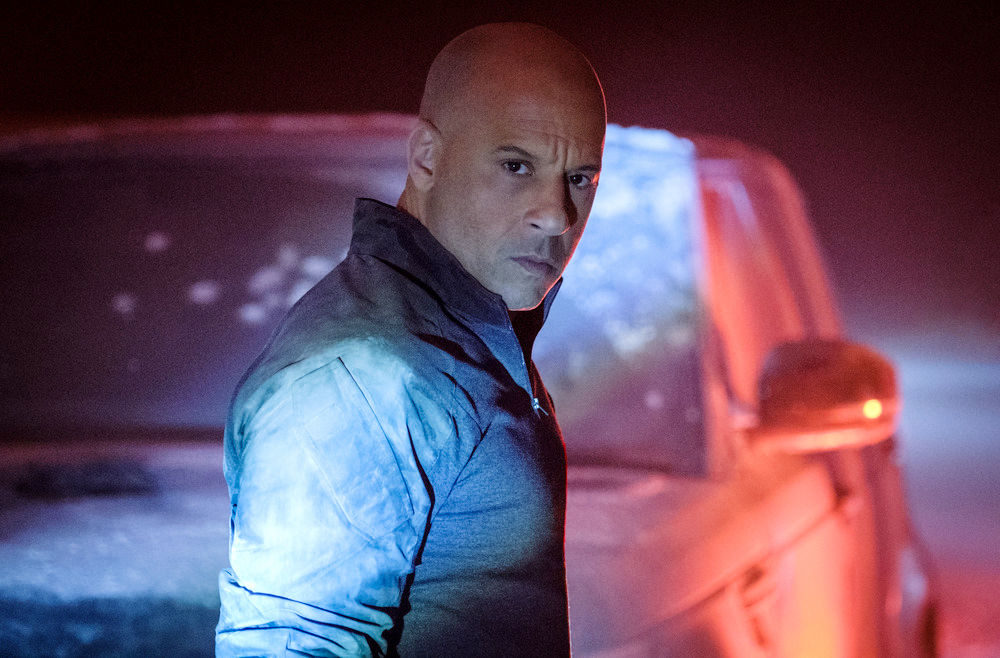Explain the visual content of the image in great detail. In the image, there is a man who closely resembles the well-known actor Vin Diesel, known for his role as Dominic Toretto in the Fast and Furious franchise. He is standing in a dimly lit, foggy setting that adds an air of mystery and intensity to the scene. The man is positioned in front of a car, turned slightly to present a three-quarter view. His gaze is directed over his shoulder, displaying a serious expression that suggests focus and determination. He is dressed in a distinctive blue jacket, which stands out against the darker, fog-covered background. The car behind him, though partially obscured by the fog and darkness, hints at the action-packed and adrenaline-fueled nature often associated with the Fast and Furious series. 